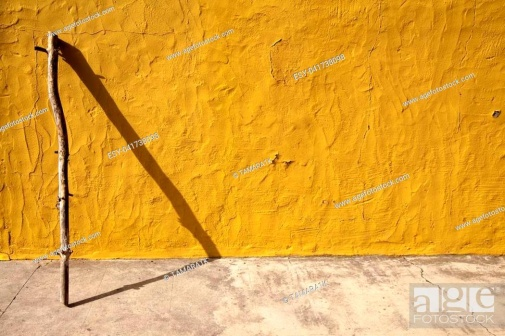If you could name this photograph, what creative title would you give it? I would title this photograph 'Silent Sentinel,' capturing the watchful and solitary presence of the stick against the enduring, bright yellow wall. 